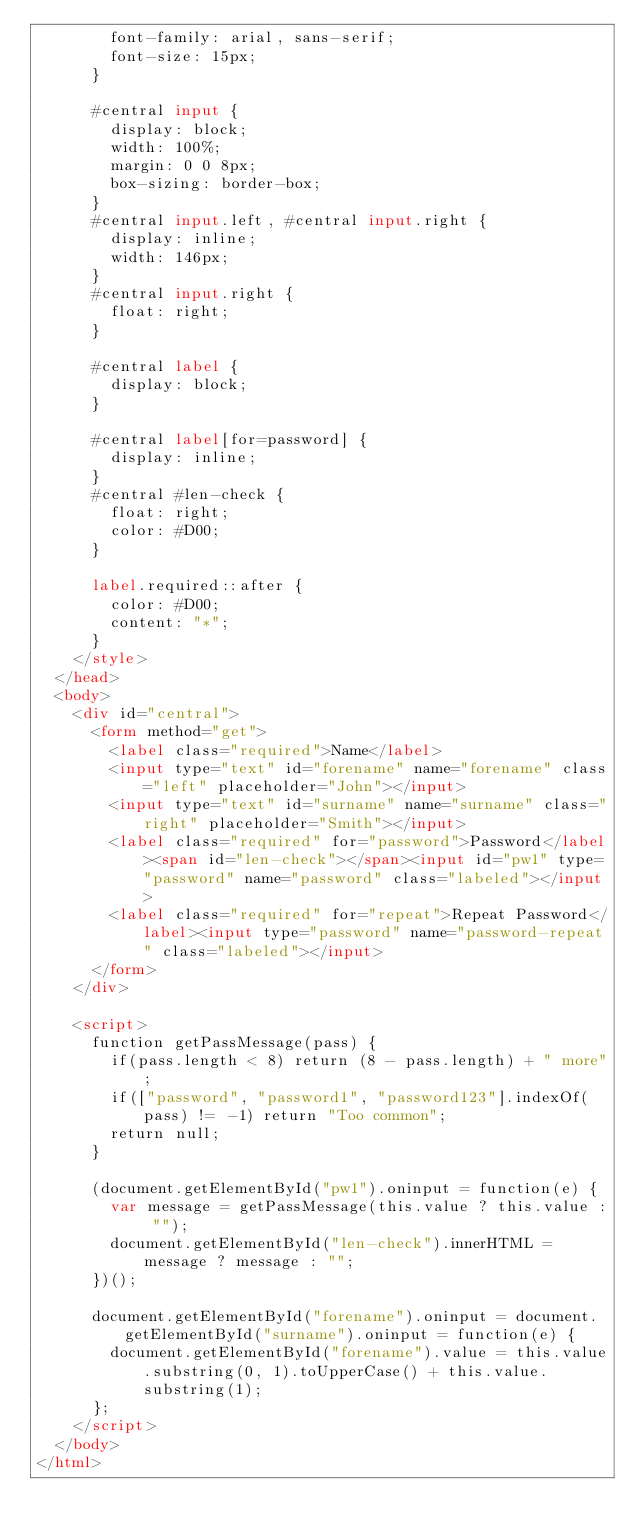Convert code to text. <code><loc_0><loc_0><loc_500><loc_500><_HTML_>				font-family: arial, sans-serif;
				font-size: 15px;
			}

			#central input {
				display: block;
				width: 100%;
				margin: 0 0 8px;
				box-sizing: border-box;
			}
			#central input.left, #central input.right {
				display: inline;
				width: 146px;
			}
			#central input.right {
				float: right;
			}

			#central label {
				display: block;
			}

			#central label[for=password] {
				display: inline;
			}
			#central #len-check {
				float: right;
				color: #D00;
			}

			label.required::after {
				color: #D00;
				content: "*";
			}
		</style>
	</head>
	<body>
		<div id="central">
			<form method="get">
				<label class="required">Name</label>
				<input type="text" id="forename" name="forename" class="left" placeholder="John"></input>
				<input type="text" id="surname" name="surname" class="right" placeholder="Smith"></input>
				<label class="required" for="password">Password</label><span id="len-check"></span><input id="pw1" type="password" name="password" class="labeled"></input>
				<label class="required" for="repeat">Repeat Password</label><input type="password" name="password-repeat" class="labeled"></input>
			</form>
		</div>

		<script>
			function getPassMessage(pass) {
				if(pass.length < 8) return (8 - pass.length) + " more";
				if(["password", "password1", "password123"].indexOf(pass) != -1) return "Too common";
				return null;
			}

			(document.getElementById("pw1").oninput = function(e) {
				var message = getPassMessage(this.value ? this.value : "");
				document.getElementById("len-check").innerHTML = message ? message : "";
			})();

			document.getElementById("forename").oninput = document.getElementById("surname").oninput = function(e) {
				document.getElementById("forename").value = this.value.substring(0, 1).toUpperCase() + this.value.substring(1);
			};
		</script>
	</body>
</html>
</code> 